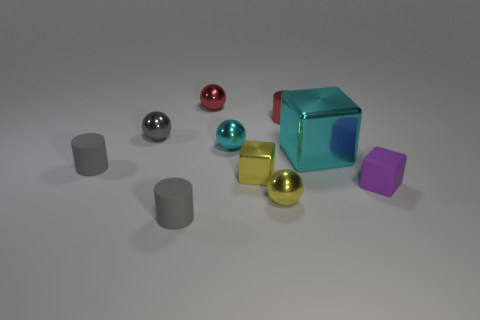How many matte things have the same color as the small metallic block?
Ensure brevity in your answer.  0. Does the cyan block have the same size as the purple matte thing?
Your answer should be compact. No. What is the size of the cyan thing that is right of the tiny cyan ball that is behind the small purple cube?
Offer a terse response. Large. Does the large shiny block have the same color as the metal block that is on the left side of the red metal cylinder?
Your response must be concise. No. Is there a red sphere of the same size as the metal cylinder?
Your answer should be very brief. Yes. What is the size of the cylinder that is to the right of the tiny red shiny sphere?
Your answer should be compact. Small. There is a cyan metal object that is on the right side of the small cyan shiny ball; are there any cyan spheres in front of it?
Offer a terse response. No. What number of other things are the same shape as the small cyan metallic object?
Provide a succinct answer. 3. Does the big object have the same shape as the gray shiny thing?
Make the answer very short. No. There is a cylinder that is in front of the gray shiny object and behind the purple rubber object; what is its color?
Offer a very short reply. Gray. 